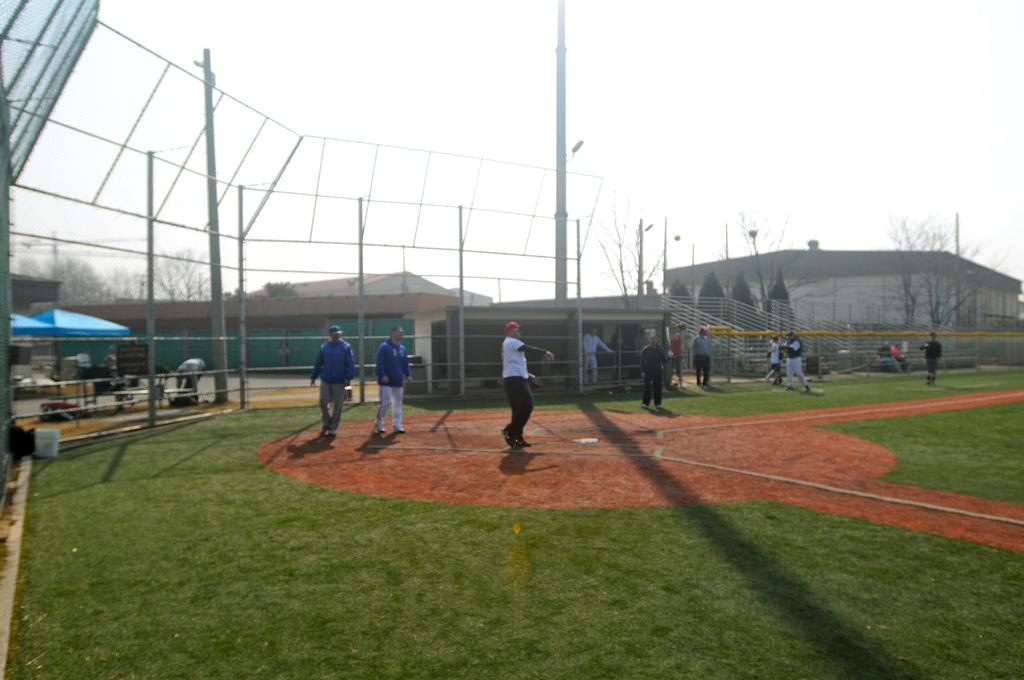How many people are in the image? There is a group of people in the image. What are the people doing in the image? The people are standing on a path and playing a game. What can be seen in the background of the image? There are umbrellas with poles, trees, buildings, chairs, tables, and the sky visible in the background. What type of alarm can be heard going off in the image? There is no alarm present in the image, and therefore no such sound can be heard. What is the wax used for in the image? There is no wax present in the image, so its use cannot be determined. 